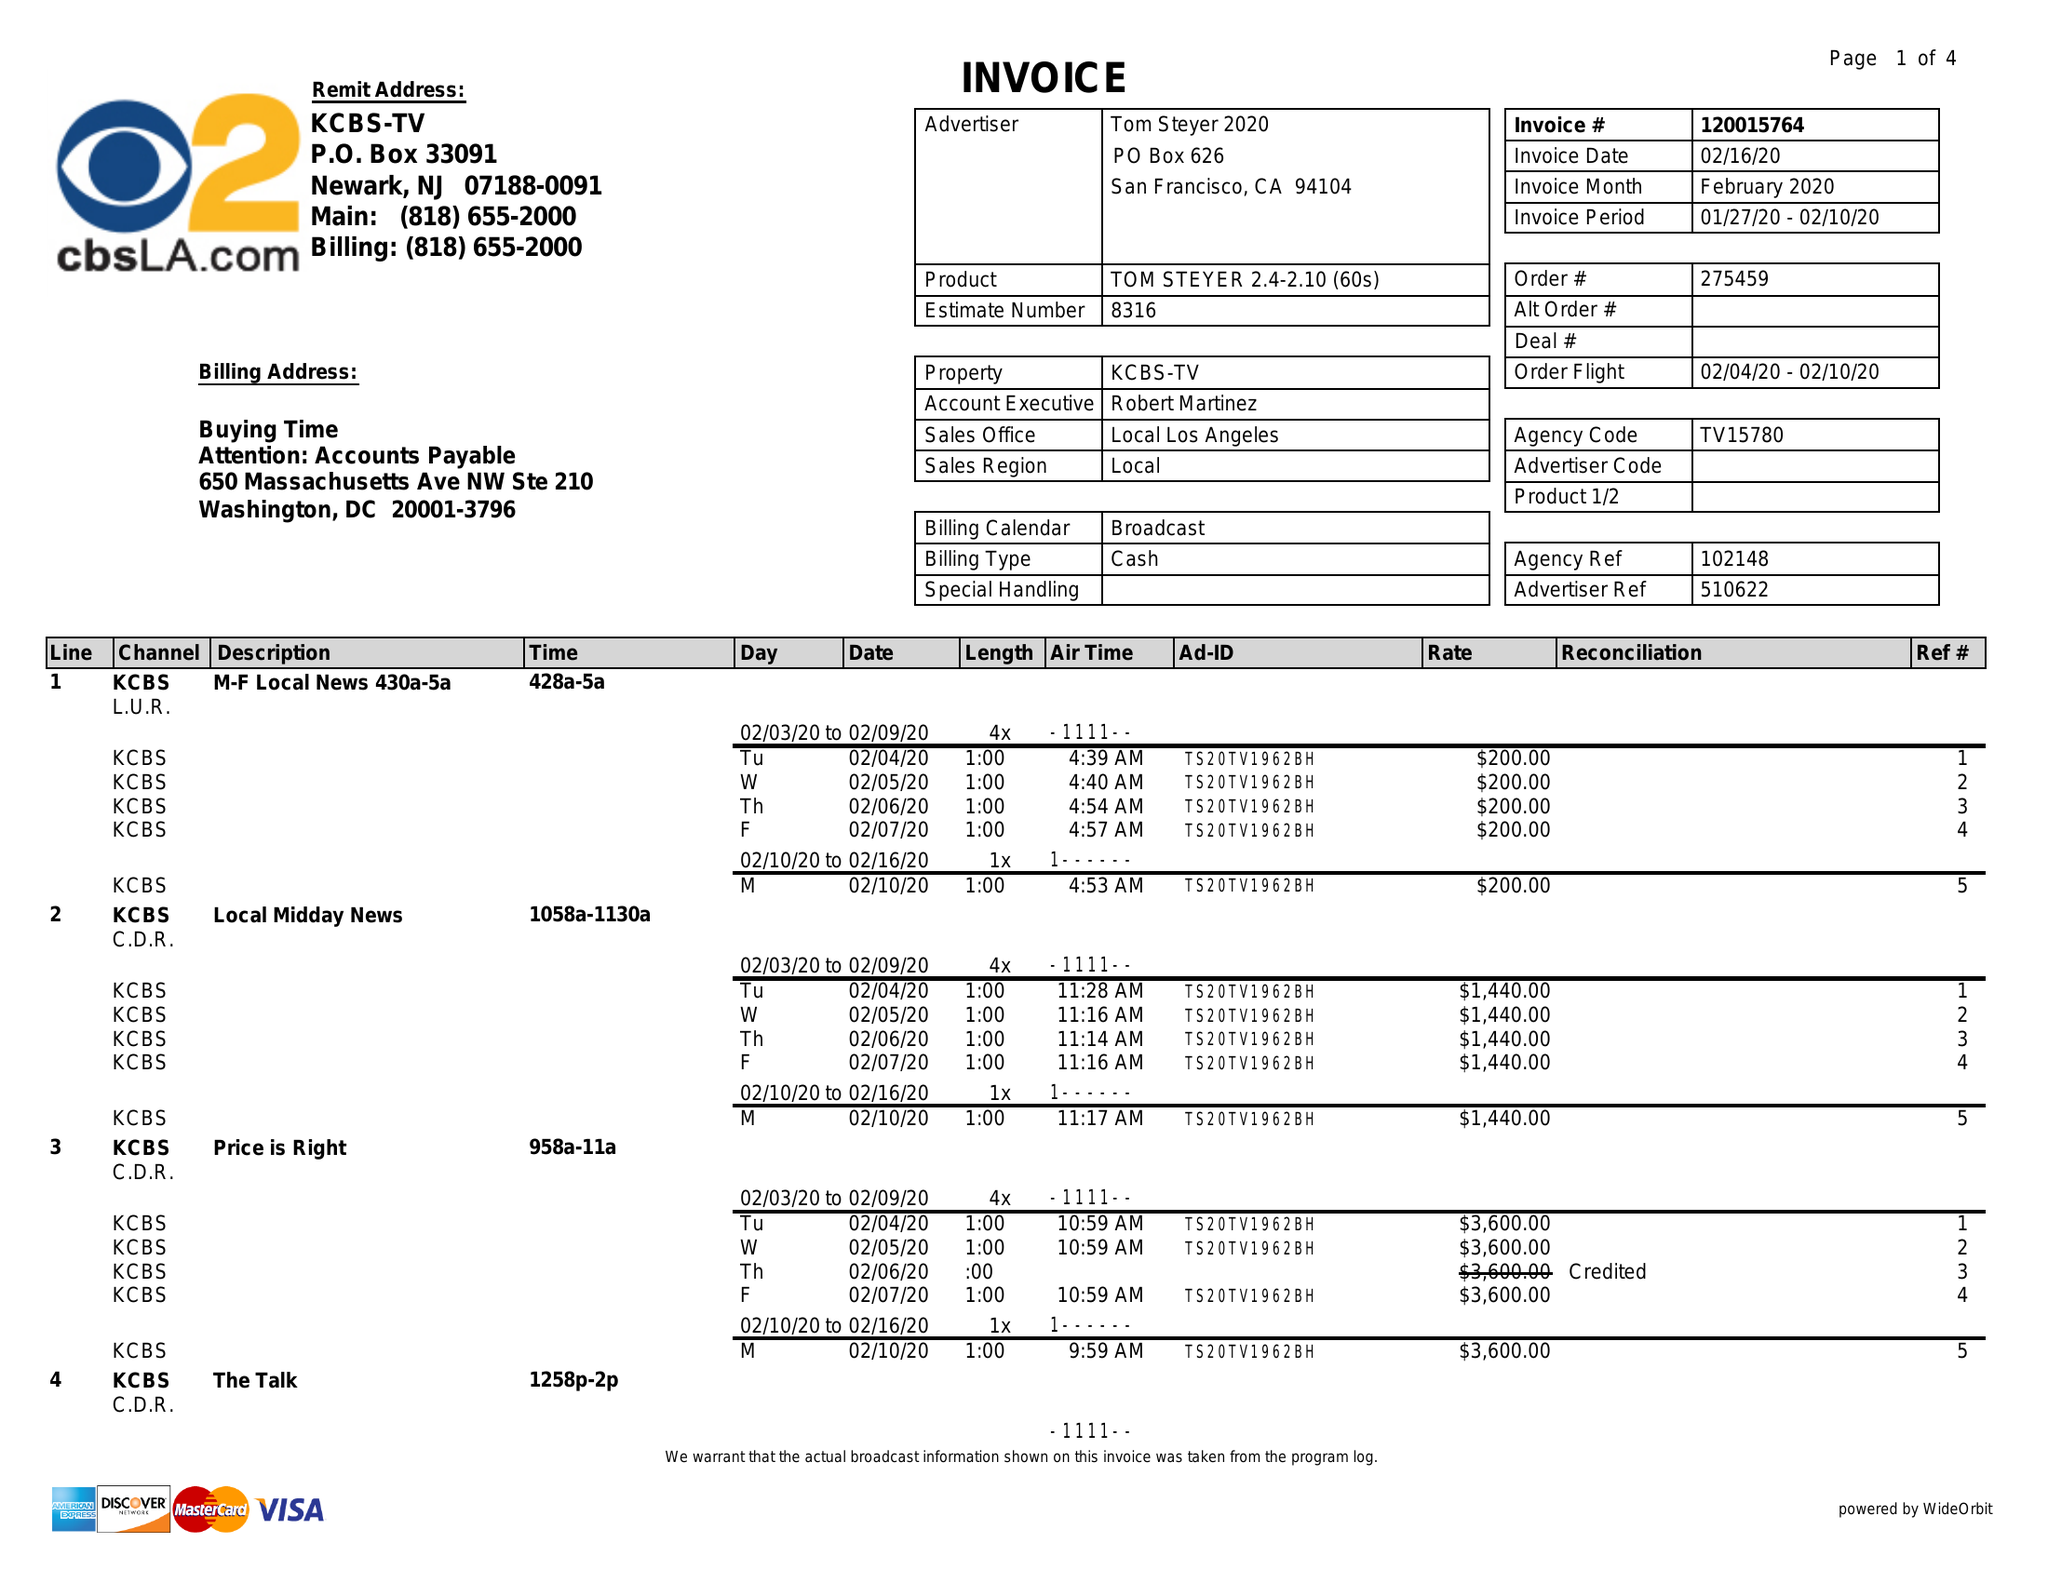What is the value for the contract_num?
Answer the question using a single word or phrase. 120015764 